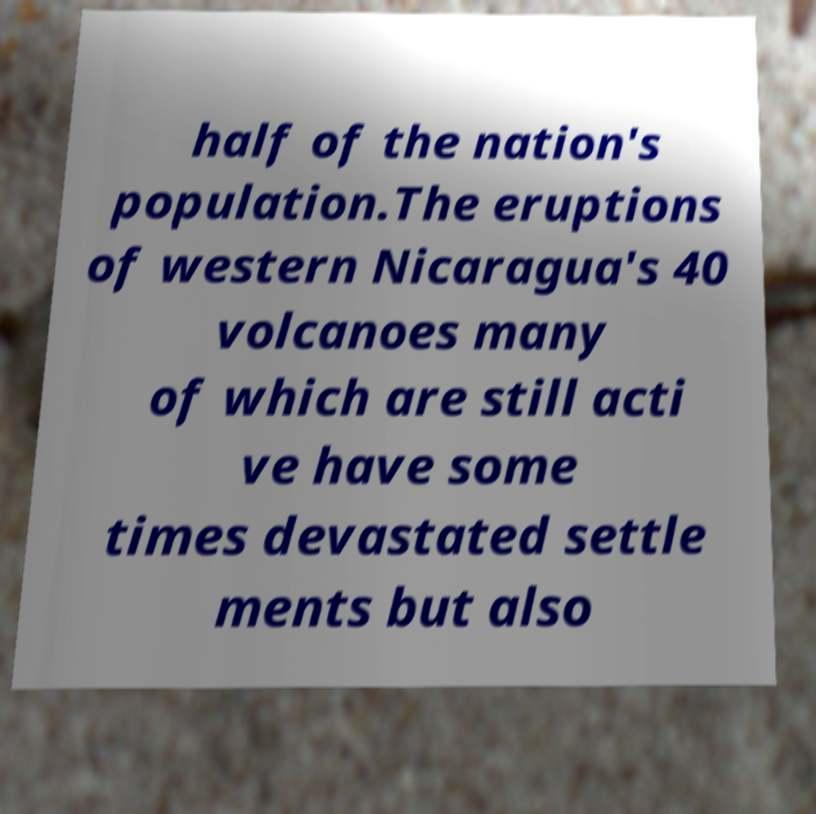Could you assist in decoding the text presented in this image and type it out clearly? half of the nation's population.The eruptions of western Nicaragua's 40 volcanoes many of which are still acti ve have some times devastated settle ments but also 